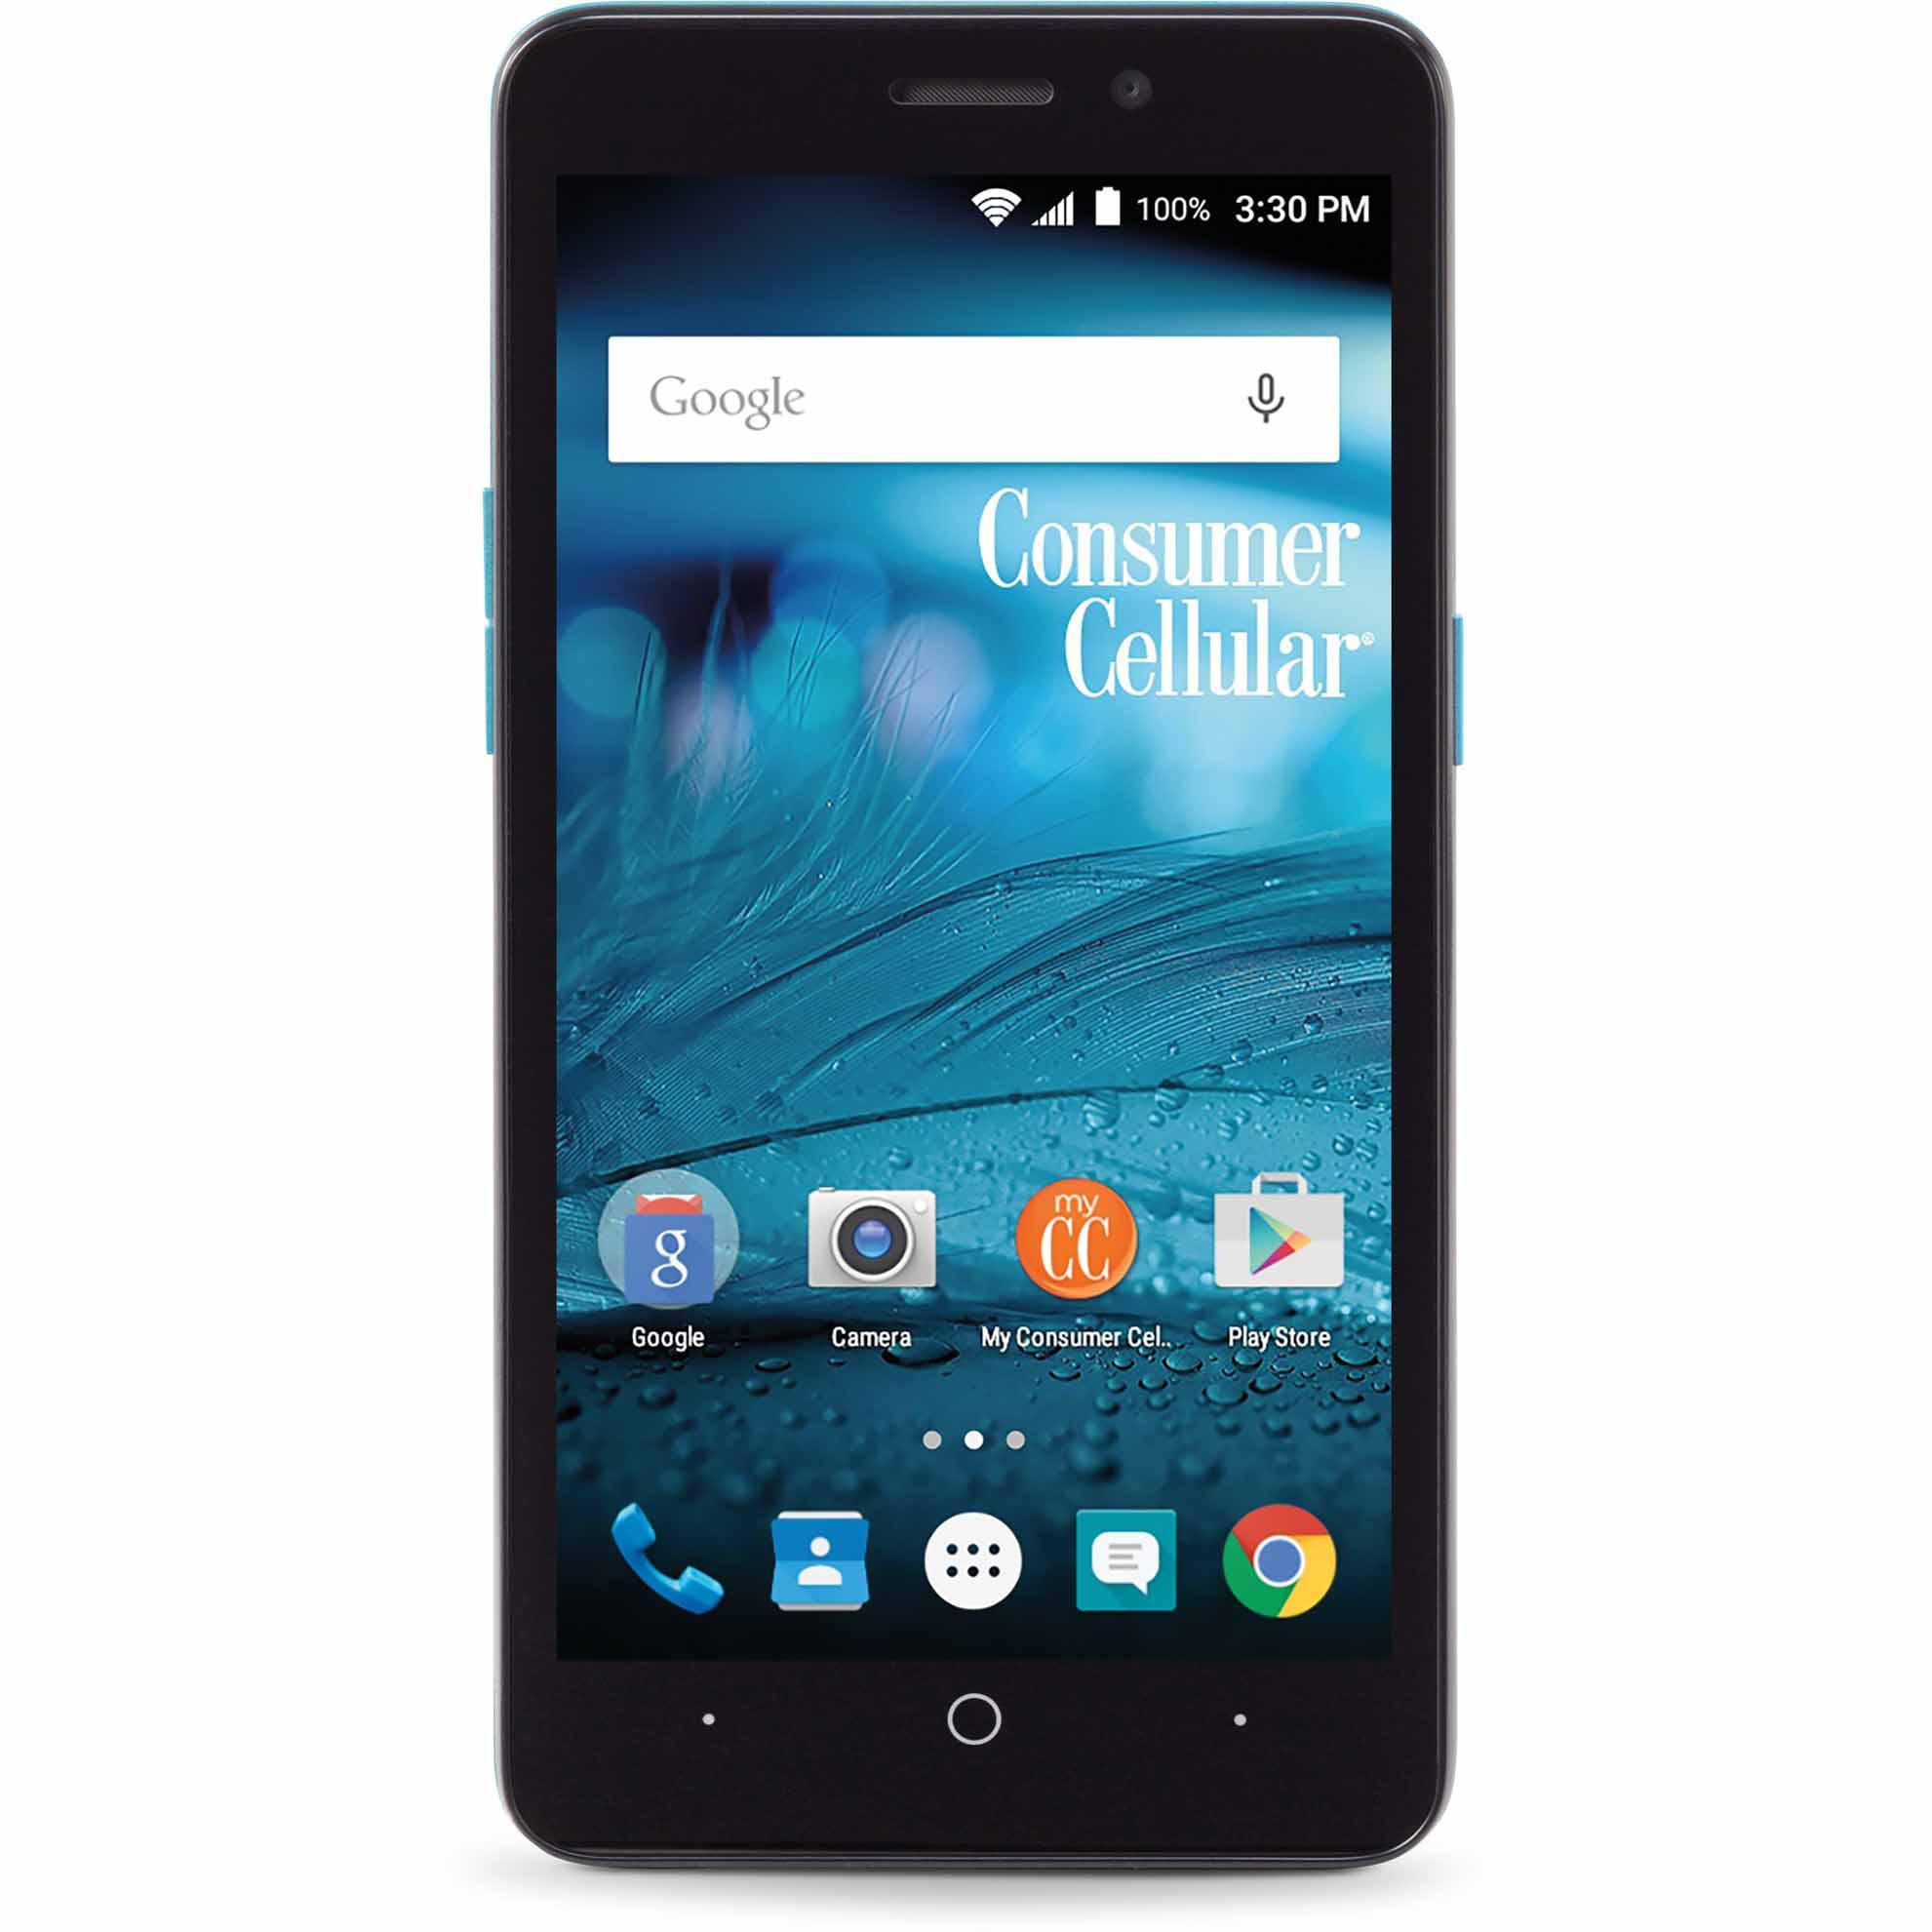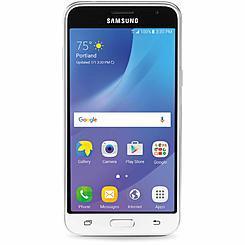The first image is the image on the left, the second image is the image on the right. Examine the images to the left and right. Is the description "The cellphone in each image shows the Google search bar on it's home page." accurate? Answer yes or no. Yes. 